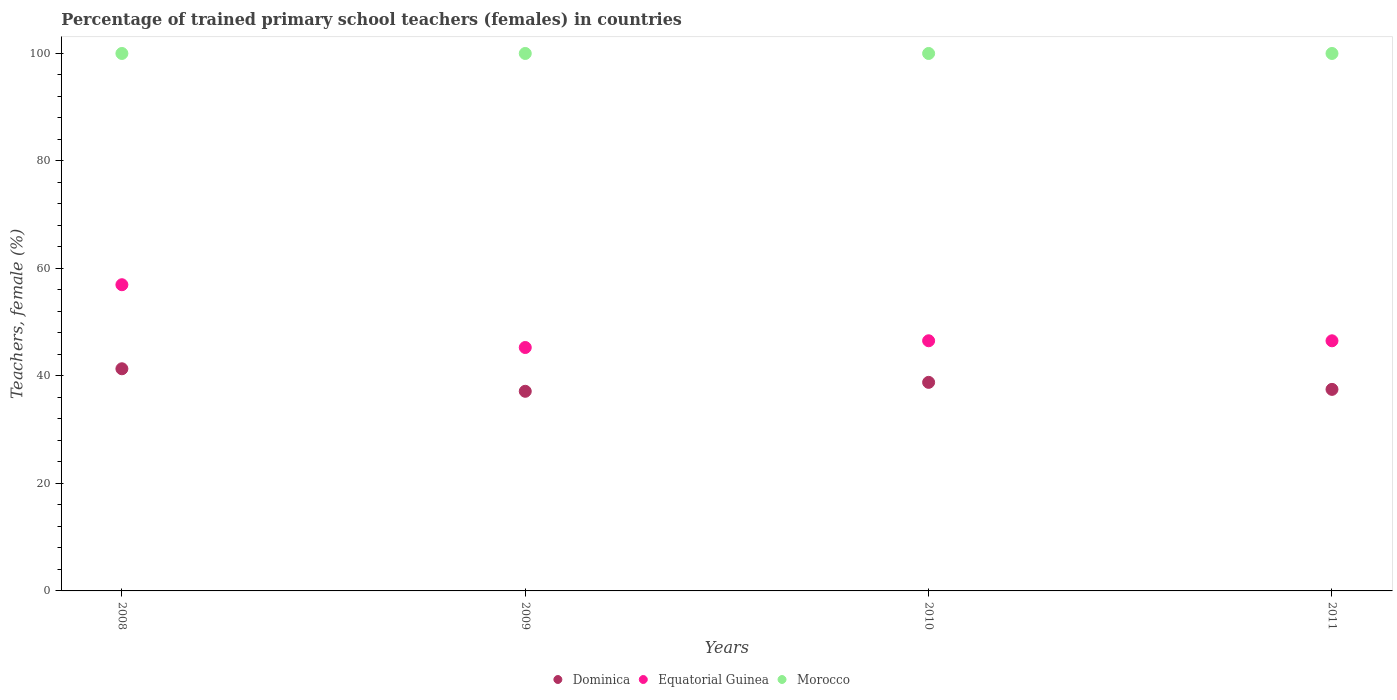How many different coloured dotlines are there?
Offer a terse response. 3. Is the number of dotlines equal to the number of legend labels?
Provide a short and direct response. Yes. Across all years, what is the maximum percentage of trained primary school teachers (females) in Dominica?
Keep it short and to the point. 41.33. Across all years, what is the minimum percentage of trained primary school teachers (females) in Morocco?
Give a very brief answer. 100. In which year was the percentage of trained primary school teachers (females) in Dominica minimum?
Offer a terse response. 2009. What is the total percentage of trained primary school teachers (females) in Dominica in the graph?
Keep it short and to the point. 154.78. What is the difference between the percentage of trained primary school teachers (females) in Dominica in 2009 and that in 2011?
Ensure brevity in your answer.  -0.36. What is the difference between the percentage of trained primary school teachers (females) in Dominica in 2011 and the percentage of trained primary school teachers (females) in Equatorial Guinea in 2010?
Your answer should be compact. -9.04. What is the average percentage of trained primary school teachers (females) in Equatorial Guinea per year?
Make the answer very short. 48.84. In the year 2008, what is the difference between the percentage of trained primary school teachers (females) in Morocco and percentage of trained primary school teachers (females) in Dominica?
Provide a short and direct response. 58.67. In how many years, is the percentage of trained primary school teachers (females) in Dominica greater than 32 %?
Ensure brevity in your answer.  4. What is the ratio of the percentage of trained primary school teachers (females) in Dominica in 2010 to that in 2011?
Your answer should be very brief. 1.03. What is the difference between the highest and the second highest percentage of trained primary school teachers (females) in Dominica?
Offer a very short reply. 2.53. Is it the case that in every year, the sum of the percentage of trained primary school teachers (females) in Dominica and percentage of trained primary school teachers (females) in Morocco  is greater than the percentage of trained primary school teachers (females) in Equatorial Guinea?
Give a very brief answer. Yes. Does the percentage of trained primary school teachers (females) in Dominica monotonically increase over the years?
Give a very brief answer. No. Is the percentage of trained primary school teachers (females) in Equatorial Guinea strictly greater than the percentage of trained primary school teachers (females) in Dominica over the years?
Your answer should be very brief. Yes. Is the percentage of trained primary school teachers (females) in Morocco strictly less than the percentage of trained primary school teachers (females) in Equatorial Guinea over the years?
Ensure brevity in your answer.  No. How many dotlines are there?
Your response must be concise. 3. How many years are there in the graph?
Your response must be concise. 4. What is the title of the graph?
Your response must be concise. Percentage of trained primary school teachers (females) in countries. Does "World" appear as one of the legend labels in the graph?
Give a very brief answer. No. What is the label or title of the Y-axis?
Provide a short and direct response. Teachers, female (%). What is the Teachers, female (%) in Dominica in 2008?
Provide a short and direct response. 41.33. What is the Teachers, female (%) of Equatorial Guinea in 2008?
Give a very brief answer. 56.97. What is the Teachers, female (%) in Dominica in 2009?
Your answer should be compact. 37.14. What is the Teachers, female (%) in Equatorial Guinea in 2009?
Your answer should be very brief. 45.29. What is the Teachers, female (%) of Dominica in 2010?
Your answer should be compact. 38.81. What is the Teachers, female (%) in Equatorial Guinea in 2010?
Provide a short and direct response. 46.54. What is the Teachers, female (%) of Morocco in 2010?
Your answer should be compact. 100. What is the Teachers, female (%) of Dominica in 2011?
Your answer should be compact. 37.5. What is the Teachers, female (%) of Equatorial Guinea in 2011?
Provide a succinct answer. 46.54. What is the Teachers, female (%) of Morocco in 2011?
Make the answer very short. 100. Across all years, what is the maximum Teachers, female (%) of Dominica?
Provide a short and direct response. 41.33. Across all years, what is the maximum Teachers, female (%) of Equatorial Guinea?
Provide a succinct answer. 56.97. Across all years, what is the maximum Teachers, female (%) in Morocco?
Ensure brevity in your answer.  100. Across all years, what is the minimum Teachers, female (%) of Dominica?
Provide a short and direct response. 37.14. Across all years, what is the minimum Teachers, female (%) of Equatorial Guinea?
Offer a terse response. 45.29. Across all years, what is the minimum Teachers, female (%) of Morocco?
Ensure brevity in your answer.  100. What is the total Teachers, female (%) in Dominica in the graph?
Keep it short and to the point. 154.78. What is the total Teachers, female (%) of Equatorial Guinea in the graph?
Provide a succinct answer. 195.34. What is the difference between the Teachers, female (%) in Dominica in 2008 and that in 2009?
Offer a very short reply. 4.19. What is the difference between the Teachers, female (%) of Equatorial Guinea in 2008 and that in 2009?
Your answer should be very brief. 11.68. What is the difference between the Teachers, female (%) of Dominica in 2008 and that in 2010?
Provide a short and direct response. 2.53. What is the difference between the Teachers, female (%) of Equatorial Guinea in 2008 and that in 2010?
Keep it short and to the point. 10.43. What is the difference between the Teachers, female (%) in Dominica in 2008 and that in 2011?
Offer a terse response. 3.83. What is the difference between the Teachers, female (%) in Equatorial Guinea in 2008 and that in 2011?
Ensure brevity in your answer.  10.43. What is the difference between the Teachers, female (%) in Dominica in 2009 and that in 2010?
Offer a very short reply. -1.66. What is the difference between the Teachers, female (%) of Equatorial Guinea in 2009 and that in 2010?
Your answer should be compact. -1.25. What is the difference between the Teachers, female (%) of Morocco in 2009 and that in 2010?
Your answer should be very brief. 0. What is the difference between the Teachers, female (%) of Dominica in 2009 and that in 2011?
Offer a terse response. -0.36. What is the difference between the Teachers, female (%) of Equatorial Guinea in 2009 and that in 2011?
Your answer should be very brief. -1.25. What is the difference between the Teachers, female (%) of Morocco in 2009 and that in 2011?
Keep it short and to the point. 0. What is the difference between the Teachers, female (%) of Dominica in 2010 and that in 2011?
Provide a short and direct response. 1.31. What is the difference between the Teachers, female (%) in Equatorial Guinea in 2010 and that in 2011?
Your answer should be very brief. 0.01. What is the difference between the Teachers, female (%) of Morocco in 2010 and that in 2011?
Make the answer very short. 0. What is the difference between the Teachers, female (%) of Dominica in 2008 and the Teachers, female (%) of Equatorial Guinea in 2009?
Provide a short and direct response. -3.96. What is the difference between the Teachers, female (%) of Dominica in 2008 and the Teachers, female (%) of Morocco in 2009?
Keep it short and to the point. -58.67. What is the difference between the Teachers, female (%) in Equatorial Guinea in 2008 and the Teachers, female (%) in Morocco in 2009?
Offer a very short reply. -43.03. What is the difference between the Teachers, female (%) of Dominica in 2008 and the Teachers, female (%) of Equatorial Guinea in 2010?
Ensure brevity in your answer.  -5.21. What is the difference between the Teachers, female (%) of Dominica in 2008 and the Teachers, female (%) of Morocco in 2010?
Provide a short and direct response. -58.67. What is the difference between the Teachers, female (%) of Equatorial Guinea in 2008 and the Teachers, female (%) of Morocco in 2010?
Your answer should be very brief. -43.03. What is the difference between the Teachers, female (%) of Dominica in 2008 and the Teachers, female (%) of Equatorial Guinea in 2011?
Offer a very short reply. -5.2. What is the difference between the Teachers, female (%) in Dominica in 2008 and the Teachers, female (%) in Morocco in 2011?
Keep it short and to the point. -58.67. What is the difference between the Teachers, female (%) of Equatorial Guinea in 2008 and the Teachers, female (%) of Morocco in 2011?
Keep it short and to the point. -43.03. What is the difference between the Teachers, female (%) of Dominica in 2009 and the Teachers, female (%) of Equatorial Guinea in 2010?
Your answer should be compact. -9.4. What is the difference between the Teachers, female (%) of Dominica in 2009 and the Teachers, female (%) of Morocco in 2010?
Your answer should be very brief. -62.86. What is the difference between the Teachers, female (%) in Equatorial Guinea in 2009 and the Teachers, female (%) in Morocco in 2010?
Offer a very short reply. -54.71. What is the difference between the Teachers, female (%) in Dominica in 2009 and the Teachers, female (%) in Equatorial Guinea in 2011?
Give a very brief answer. -9.39. What is the difference between the Teachers, female (%) in Dominica in 2009 and the Teachers, female (%) in Morocco in 2011?
Offer a very short reply. -62.86. What is the difference between the Teachers, female (%) in Equatorial Guinea in 2009 and the Teachers, female (%) in Morocco in 2011?
Your response must be concise. -54.71. What is the difference between the Teachers, female (%) in Dominica in 2010 and the Teachers, female (%) in Equatorial Guinea in 2011?
Provide a succinct answer. -7.73. What is the difference between the Teachers, female (%) of Dominica in 2010 and the Teachers, female (%) of Morocco in 2011?
Provide a short and direct response. -61.19. What is the difference between the Teachers, female (%) in Equatorial Guinea in 2010 and the Teachers, female (%) in Morocco in 2011?
Provide a succinct answer. -53.46. What is the average Teachers, female (%) of Dominica per year?
Your answer should be very brief. 38.7. What is the average Teachers, female (%) of Equatorial Guinea per year?
Your answer should be compact. 48.84. In the year 2008, what is the difference between the Teachers, female (%) in Dominica and Teachers, female (%) in Equatorial Guinea?
Provide a succinct answer. -15.64. In the year 2008, what is the difference between the Teachers, female (%) in Dominica and Teachers, female (%) in Morocco?
Make the answer very short. -58.67. In the year 2008, what is the difference between the Teachers, female (%) of Equatorial Guinea and Teachers, female (%) of Morocco?
Your answer should be very brief. -43.03. In the year 2009, what is the difference between the Teachers, female (%) of Dominica and Teachers, female (%) of Equatorial Guinea?
Your response must be concise. -8.15. In the year 2009, what is the difference between the Teachers, female (%) in Dominica and Teachers, female (%) in Morocco?
Offer a very short reply. -62.86. In the year 2009, what is the difference between the Teachers, female (%) in Equatorial Guinea and Teachers, female (%) in Morocco?
Make the answer very short. -54.71. In the year 2010, what is the difference between the Teachers, female (%) in Dominica and Teachers, female (%) in Equatorial Guinea?
Ensure brevity in your answer.  -7.74. In the year 2010, what is the difference between the Teachers, female (%) in Dominica and Teachers, female (%) in Morocco?
Give a very brief answer. -61.19. In the year 2010, what is the difference between the Teachers, female (%) of Equatorial Guinea and Teachers, female (%) of Morocco?
Your answer should be very brief. -53.46. In the year 2011, what is the difference between the Teachers, female (%) of Dominica and Teachers, female (%) of Equatorial Guinea?
Your answer should be compact. -9.04. In the year 2011, what is the difference between the Teachers, female (%) of Dominica and Teachers, female (%) of Morocco?
Offer a terse response. -62.5. In the year 2011, what is the difference between the Teachers, female (%) of Equatorial Guinea and Teachers, female (%) of Morocco?
Your answer should be compact. -53.46. What is the ratio of the Teachers, female (%) of Dominica in 2008 to that in 2009?
Make the answer very short. 1.11. What is the ratio of the Teachers, female (%) in Equatorial Guinea in 2008 to that in 2009?
Give a very brief answer. 1.26. What is the ratio of the Teachers, female (%) of Dominica in 2008 to that in 2010?
Provide a succinct answer. 1.07. What is the ratio of the Teachers, female (%) in Equatorial Guinea in 2008 to that in 2010?
Offer a terse response. 1.22. What is the ratio of the Teachers, female (%) in Dominica in 2008 to that in 2011?
Offer a very short reply. 1.1. What is the ratio of the Teachers, female (%) of Equatorial Guinea in 2008 to that in 2011?
Make the answer very short. 1.22. What is the ratio of the Teachers, female (%) of Morocco in 2008 to that in 2011?
Your response must be concise. 1. What is the ratio of the Teachers, female (%) in Dominica in 2009 to that in 2010?
Make the answer very short. 0.96. What is the ratio of the Teachers, female (%) in Equatorial Guinea in 2009 to that in 2010?
Ensure brevity in your answer.  0.97. What is the ratio of the Teachers, female (%) of Equatorial Guinea in 2009 to that in 2011?
Your response must be concise. 0.97. What is the ratio of the Teachers, female (%) in Dominica in 2010 to that in 2011?
Keep it short and to the point. 1.03. What is the difference between the highest and the second highest Teachers, female (%) of Dominica?
Offer a terse response. 2.53. What is the difference between the highest and the second highest Teachers, female (%) of Equatorial Guinea?
Your response must be concise. 10.43. What is the difference between the highest and the lowest Teachers, female (%) in Dominica?
Your answer should be compact. 4.19. What is the difference between the highest and the lowest Teachers, female (%) in Equatorial Guinea?
Offer a very short reply. 11.68. What is the difference between the highest and the lowest Teachers, female (%) of Morocco?
Make the answer very short. 0. 